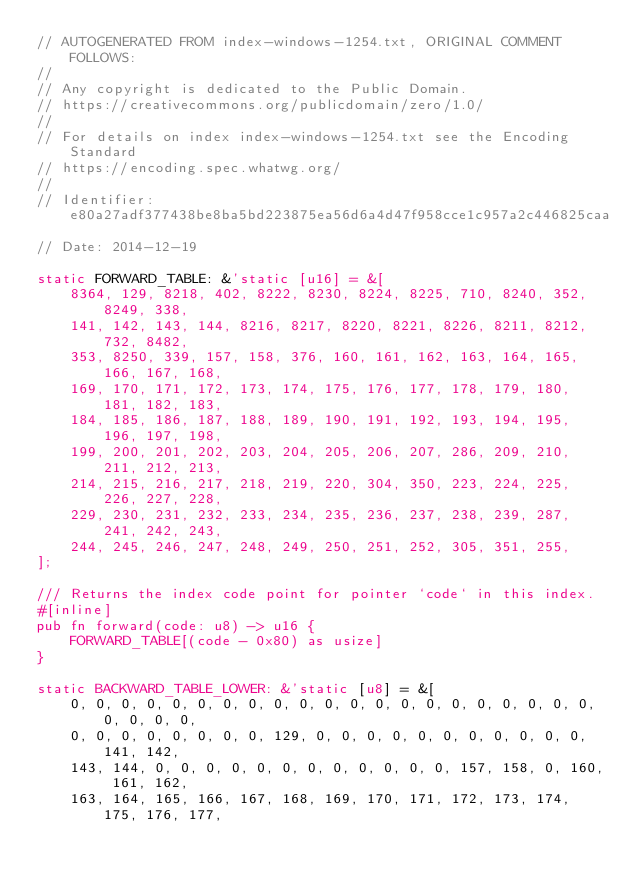Convert code to text. <code><loc_0><loc_0><loc_500><loc_500><_Rust_>// AUTOGENERATED FROM index-windows-1254.txt, ORIGINAL COMMENT FOLLOWS:
//
// Any copyright is dedicated to the Public Domain.
// https://creativecommons.org/publicdomain/zero/1.0/
//
// For details on index index-windows-1254.txt see the Encoding Standard
// https://encoding.spec.whatwg.org/
//
// Identifier: e80a27adf377438be8ba5bd223875ea56d6a4d47f958cce1c957a2c446825caa
// Date: 2014-12-19

static FORWARD_TABLE: &'static [u16] = &[
    8364, 129, 8218, 402, 8222, 8230, 8224, 8225, 710, 8240, 352, 8249, 338,
    141, 142, 143, 144, 8216, 8217, 8220, 8221, 8226, 8211, 8212, 732, 8482,
    353, 8250, 339, 157, 158, 376, 160, 161, 162, 163, 164, 165, 166, 167, 168,
    169, 170, 171, 172, 173, 174, 175, 176, 177, 178, 179, 180, 181, 182, 183,
    184, 185, 186, 187, 188, 189, 190, 191, 192, 193, 194, 195, 196, 197, 198,
    199, 200, 201, 202, 203, 204, 205, 206, 207, 286, 209, 210, 211, 212, 213,
    214, 215, 216, 217, 218, 219, 220, 304, 350, 223, 224, 225, 226, 227, 228,
    229, 230, 231, 232, 233, 234, 235, 236, 237, 238, 239, 287, 241, 242, 243,
    244, 245, 246, 247, 248, 249, 250, 251, 252, 305, 351, 255,
];

/// Returns the index code point for pointer `code` in this index.
#[inline]
pub fn forward(code: u8) -> u16 {
    FORWARD_TABLE[(code - 0x80) as usize]
}

static BACKWARD_TABLE_LOWER: &'static [u8] = &[
    0, 0, 0, 0, 0, 0, 0, 0, 0, 0, 0, 0, 0, 0, 0, 0, 0, 0, 0, 0, 0, 0, 0, 0, 0,
    0, 0, 0, 0, 0, 0, 0, 0, 129, 0, 0, 0, 0, 0, 0, 0, 0, 0, 0, 0, 141, 142,
    143, 144, 0, 0, 0, 0, 0, 0, 0, 0, 0, 0, 0, 0, 157, 158, 0, 160, 161, 162,
    163, 164, 165, 166, 167, 168, 169, 170, 171, 172, 173, 174, 175, 176, 177,</code> 